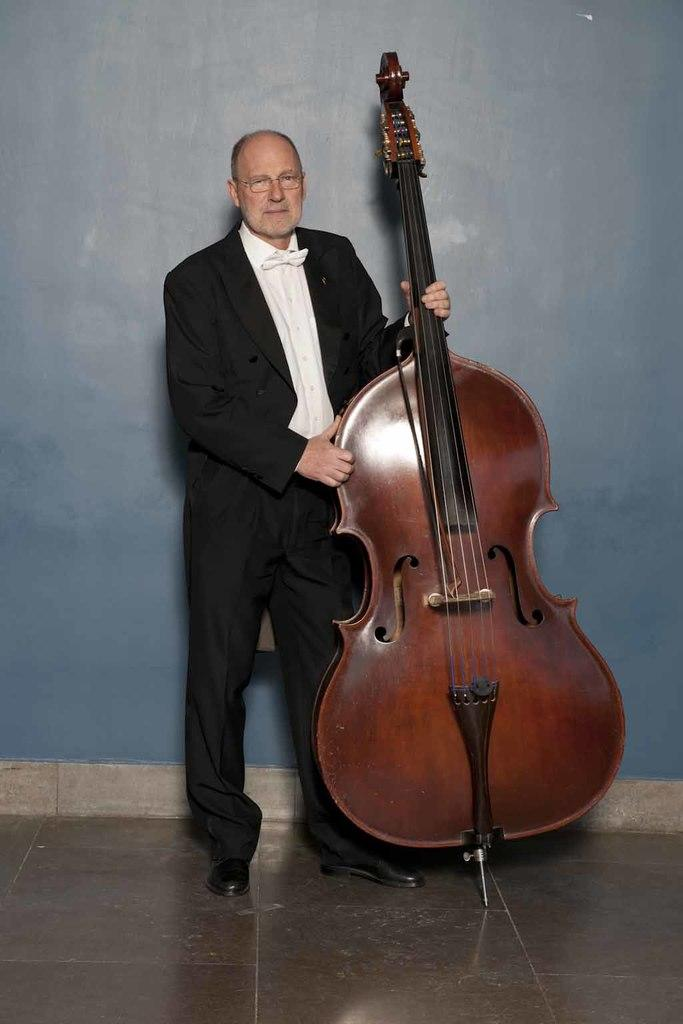What is the main subject of the image? There is a person in the image. What is the person doing in the image? The person is standing and holding a guitar. What can be seen in the background of the image? There is a wall in the background of the image. What type of apparatus is the governor using to communicate with the crowd in the image? There is no governor or crowd present in the image, and no apparatus is being used for communication. 